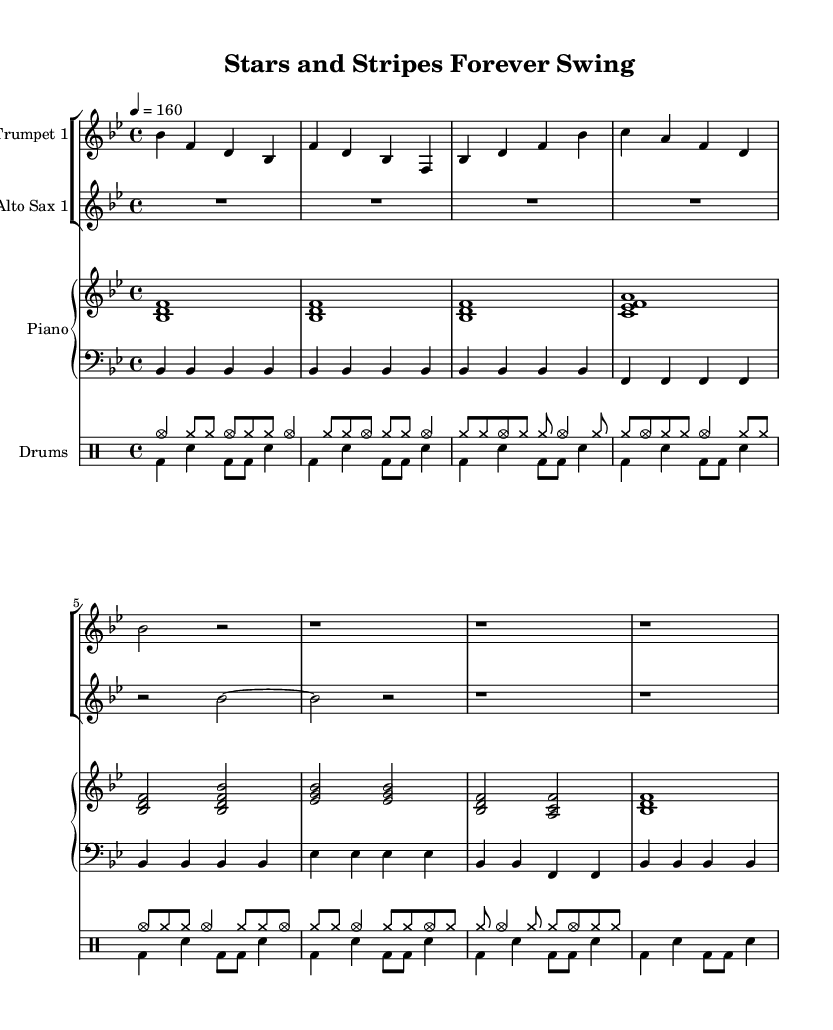What is the key signature of this music? The key signature is B flat major, identified by the presence of two flat notes (B flat and E flat) in the key signature shown at the beginning of the staff.
Answer: B flat major What is the time signature of this music? The time signature, located at the beginning of the score, indicates the rhythmic structure of the music, which is 4 beats per measure, as shown by the notation "4/4."
Answer: 4/4 What is the tempo marking of this piece? The tempo marking is indicated above the staff as "4 = 160," which indicates that there should be 160 quarter-note beats per minute throughout the piece.
Answer: 160 How many measures are included in the intro section? The intro section contains 4 measures, as each measure is separated by a vertical line in the music notation, and counting them reveals a total of 4.
Answer: 4 What are the instruments featured in this score? The featured instruments are identified in the staff labels, which include Trumpet 1, Alto Sax 1, Piano, and Drums.
Answer: Trumpet 1, Alto Sax 1, Piano, Drums What is the predominant musical style of this piece? The musical style can be inferred from the title "Stars and Stripes Forever Swing," suggesting that it employs elements typical of big band swing music from the World War II era, characterized by its upbeat rhythm and orchestration.
Answer: Swing 